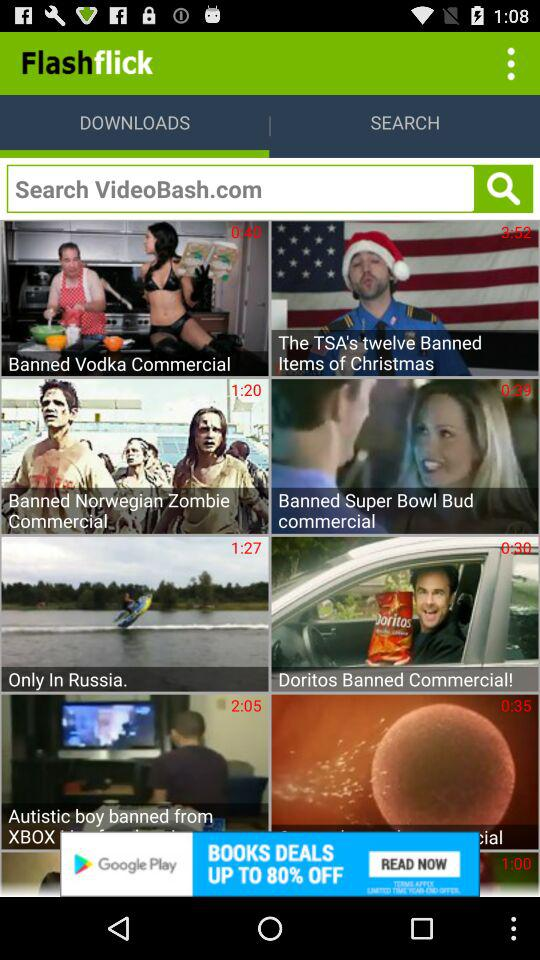What is the searched item?
When the provided information is insufficient, respond with <no answer>. <no answer> 